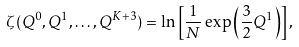Convert formula to latex. <formula><loc_0><loc_0><loc_500><loc_500>\zeta ( Q ^ { 0 } , Q ^ { 1 } , \dots , Q ^ { K + 3 } ) = \ln \left [ \frac { 1 } { N } \exp \left ( \frac { 3 } { 2 } Q ^ { 1 } \right ) \right ] ,</formula> 